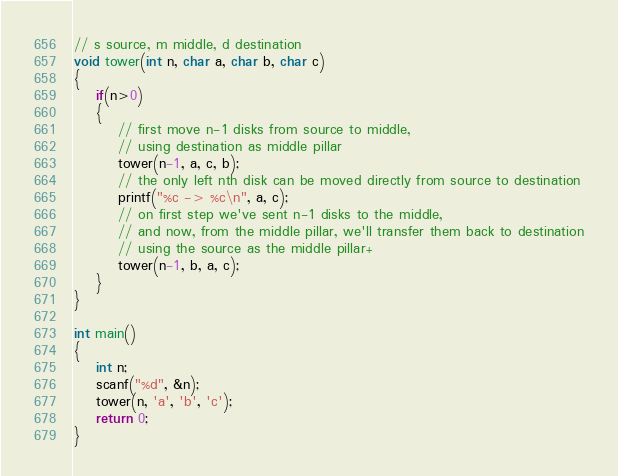<code> <loc_0><loc_0><loc_500><loc_500><_C++_>// s source, m middle, d destination
void tower(int n, char a, char b, char c)
{
    if(n>0)
    {
        // first move n-1 disks from source to middle,
        // using destination as middle pillar
        tower(n-1, a, c, b);
        // the only left nth disk can be moved directly from source to destination
        printf("%c -> %c\n", a, c);
        // on first step we've sent n-1 disks to the middle,
        // and now, from the middle pillar, we'll transfer them back to destination
        // using the source as the middle pillar+
        tower(n-1, b, a, c);
    }
}

int main()
{
    int n;
    scanf("%d", &n);
    tower(n, 'a', 'b', 'c');
    return 0;
}
</code> 